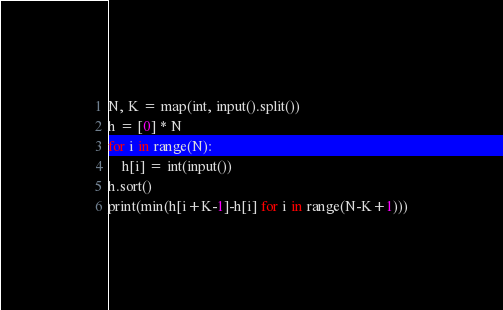Convert code to text. <code><loc_0><loc_0><loc_500><loc_500><_Python_>N, K = map(int, input().split())
h = [0] * N
for i in range(N):
    h[i] = int(input())
h.sort()
print(min(h[i+K-1]-h[i] for i in range(N-K+1)))
</code> 